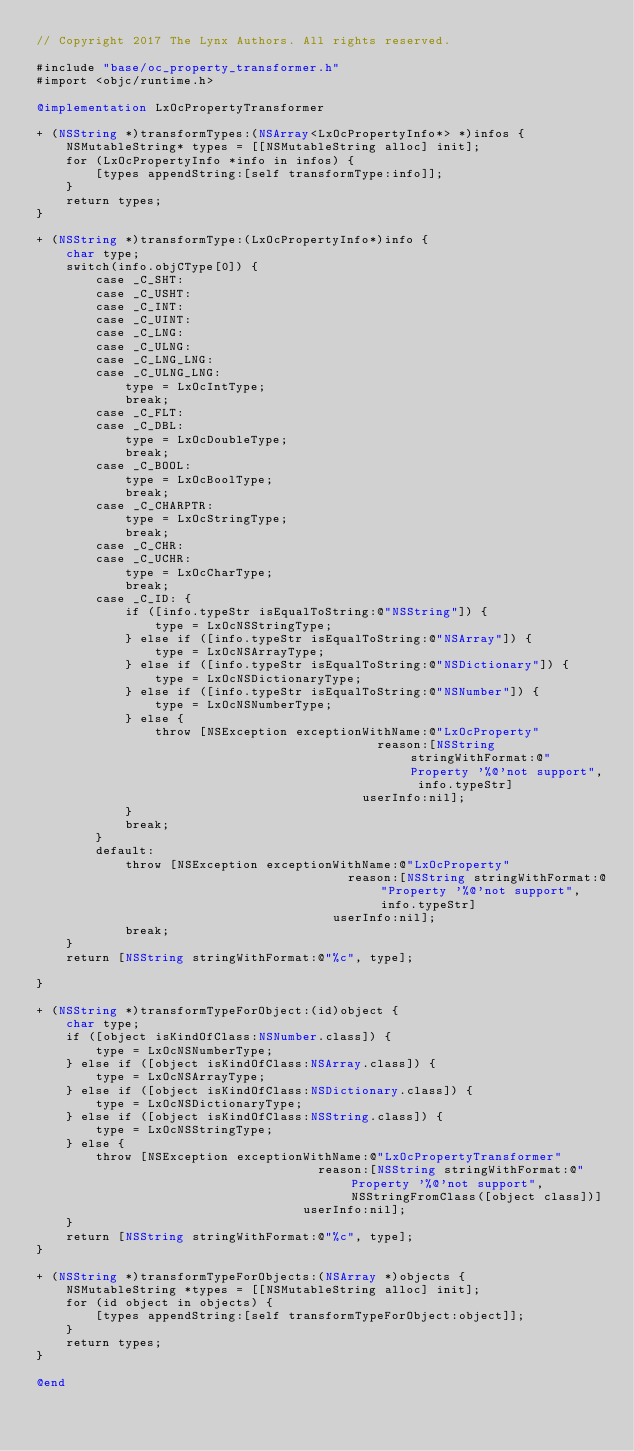Convert code to text. <code><loc_0><loc_0><loc_500><loc_500><_ObjectiveC_>// Copyright 2017 The Lynx Authors. All rights reserved.

#include "base/oc_property_transformer.h"
#import <objc/runtime.h>

@implementation LxOcPropertyTransformer

+ (NSString *)transformTypes:(NSArray<LxOcPropertyInfo*> *)infos {
    NSMutableString* types = [[NSMutableString alloc] init];
    for (LxOcPropertyInfo *info in infos) {
        [types appendString:[self transformType:info]];
    }
    return types;
}

+ (NSString *)transformType:(LxOcPropertyInfo*)info {
    char type;
    switch(info.objCType[0]) {
        case _C_SHT:
        case _C_USHT:
        case _C_INT:
        case _C_UINT:
        case _C_LNG:
        case _C_ULNG:
        case _C_LNG_LNG:
        case _C_ULNG_LNG:
            type = LxOcIntType;
            break;
        case _C_FLT:
        case _C_DBL:
            type = LxOcDoubleType;
            break;
        case _C_BOOL:
            type = LxOcBoolType;
            break;
        case _C_CHARPTR:
            type = LxOcStringType;
            break;
        case _C_CHR:
        case _C_UCHR:
            type = LxOcCharType;
            break;
        case _C_ID: {
            if ([info.typeStr isEqualToString:@"NSString"]) {
                type = LxOcNSStringType;
            } else if ([info.typeStr isEqualToString:@"NSArray"]) {
                type = LxOcNSArrayType;
            } else if ([info.typeStr isEqualToString:@"NSDictionary"]) {
                type = LxOcNSDictionaryType;
            } else if ([info.typeStr isEqualToString:@"NSNumber"]) {
                type = LxOcNSNumberType;
            } else {
                throw [NSException exceptionWithName:@"LxOcProperty"
                                              reason:[NSString stringWithFormat:@"Property '%@'not support", info.typeStr]
                                            userInfo:nil];
            }
            break;
        }
        default:
            throw [NSException exceptionWithName:@"LxOcProperty"
                                          reason:[NSString stringWithFormat:@"Property '%@'not support", info.typeStr]
                                        userInfo:nil];
            break;
    }
    return [NSString stringWithFormat:@"%c", type];
    
}

+ (NSString *)transformTypeForObject:(id)object {
    char type;
    if ([object isKindOfClass:NSNumber.class]) {
        type = LxOcNSNumberType;
    } else if ([object isKindOfClass:NSArray.class]) {
        type = LxOcNSArrayType;
    } else if ([object isKindOfClass:NSDictionary.class]) {
        type = LxOcNSDictionaryType;
    } else if ([object isKindOfClass:NSString.class]) {
        type = LxOcNSStringType;
    } else {
        throw [NSException exceptionWithName:@"LxOcPropertyTransformer"
                                      reason:[NSString stringWithFormat:@"Property '%@'not support", NSStringFromClass([object class])]
                                    userInfo:nil];
    }
    return [NSString stringWithFormat:@"%c", type];
}

+ (NSString *)transformTypeForObjects:(NSArray *)objects {
    NSMutableString *types = [[NSMutableString alloc] init];
    for (id object in objects) {
        [types appendString:[self transformTypeForObject:object]];
    }
    return types;
}

@end
</code> 